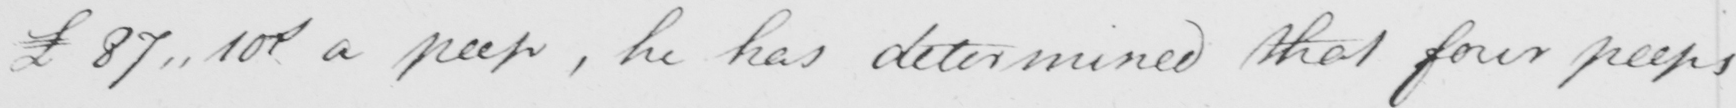Transcribe the text shown in this historical manuscript line. £87 . 10  <gap/>  a peep , he has determined that four peeps 